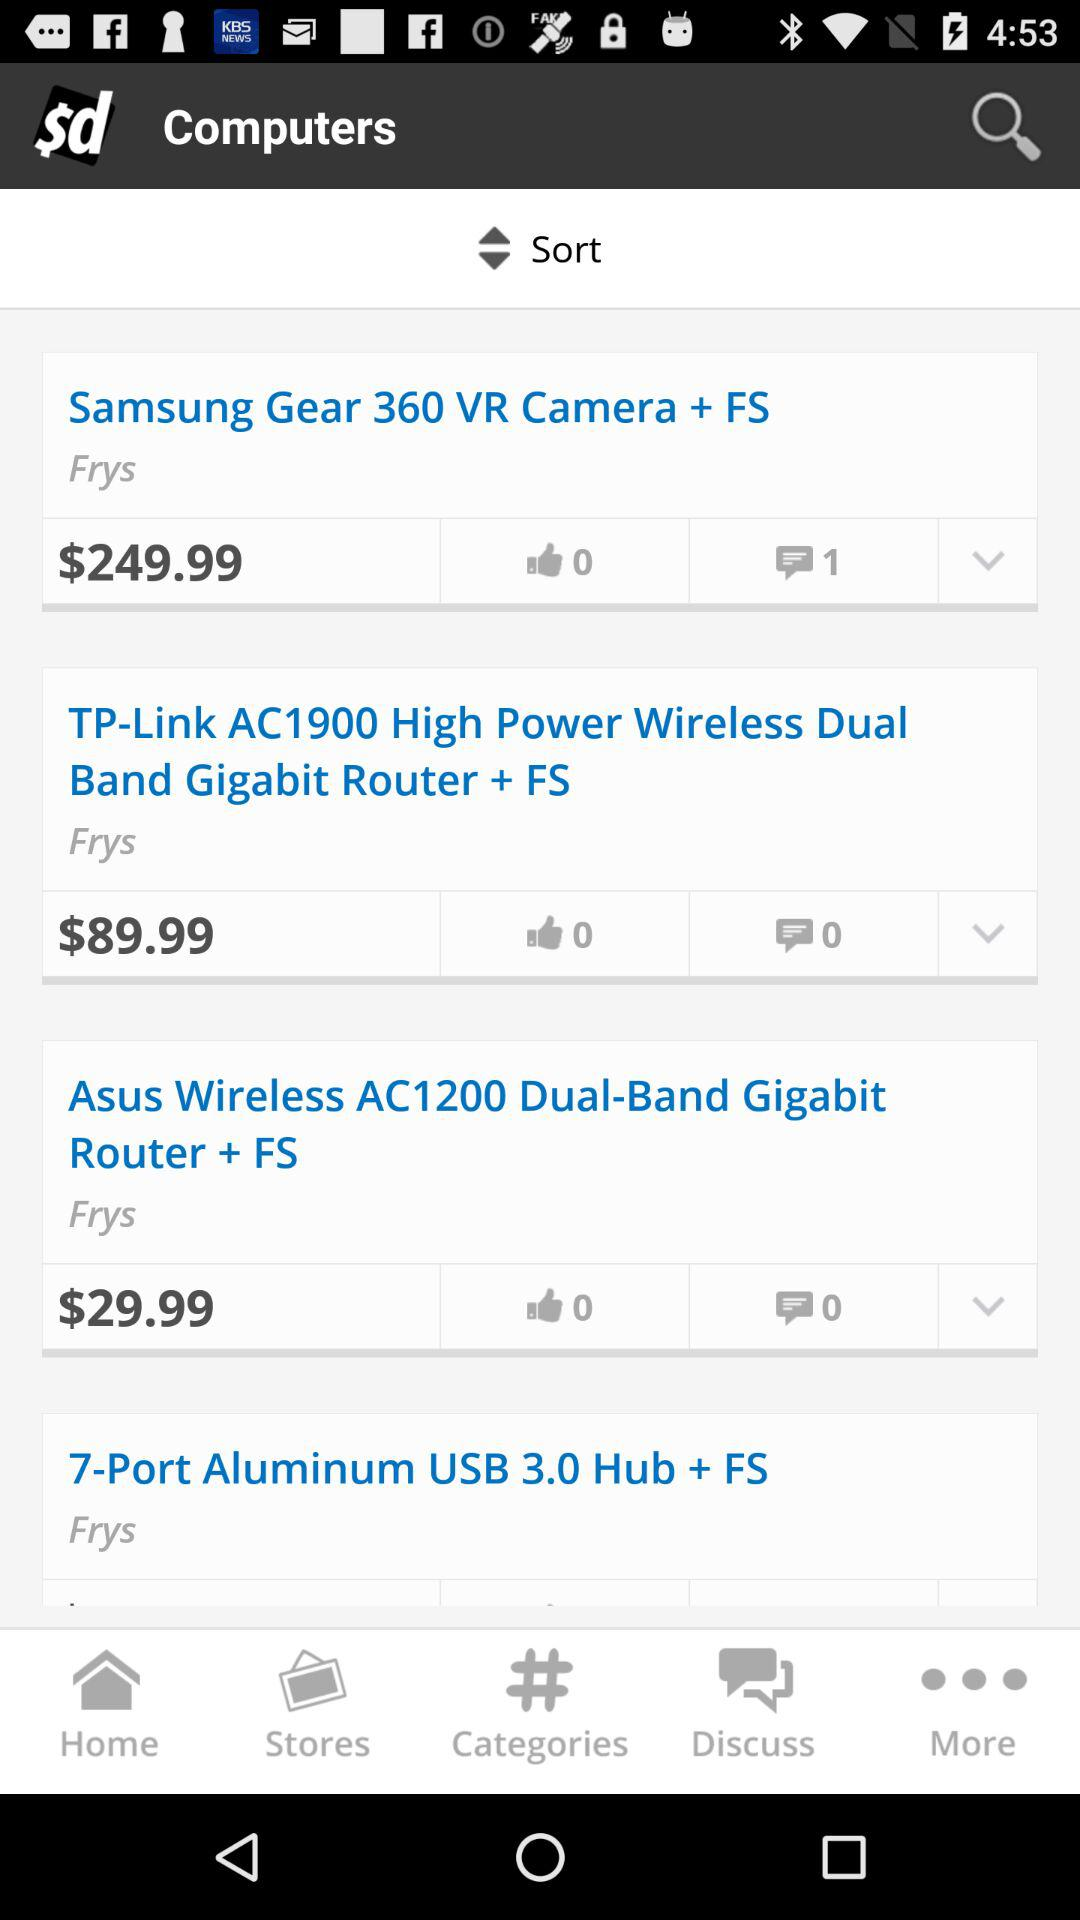How many likes are there for the "Samsung Gear 360 VR Camera + FS"? There are 0 likes for the "Samsung Gear 360 VR Camera + FS". 